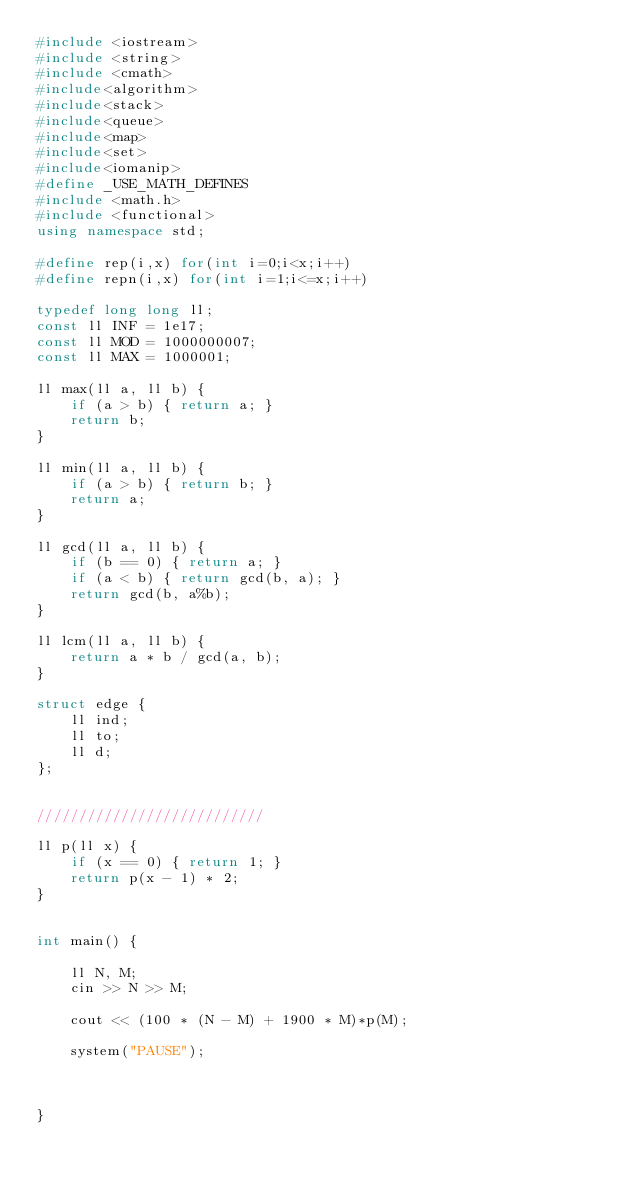<code> <loc_0><loc_0><loc_500><loc_500><_C++_>#include <iostream>
#include <string>
#include <cmath>
#include<algorithm>
#include<stack>
#include<queue>
#include<map>
#include<set>
#include<iomanip>
#define _USE_MATH_DEFINES
#include <math.h>
#include <functional>
using namespace std;

#define rep(i,x) for(int i=0;i<x;i++)
#define repn(i,x) for(int i=1;i<=x;i++)

typedef long long ll;
const ll INF = 1e17;
const ll MOD = 1000000007;
const ll MAX = 1000001;

ll max(ll a, ll b) {
	if (a > b) { return a; }
	return b;
}

ll min(ll a, ll b) {
	if (a > b) { return b; }
	return a;
}

ll gcd(ll a, ll b) {
	if (b == 0) { return a; }
	if (a < b) { return gcd(b, a); }
	return gcd(b, a%b);
}

ll lcm(ll a, ll b) {
	return a * b / gcd(a, b);
}

struct edge {
	ll ind;
	ll to;
	ll d;
};


///////////////////////////

ll p(ll x) {
	if (x == 0) { return 1; }
	return p(x - 1) * 2;
}


int main() {

	ll N, M;
	cin >> N >> M;

	cout << (100 * (N - M) + 1900 * M)*p(M);

	system("PAUSE");

	

}
</code> 